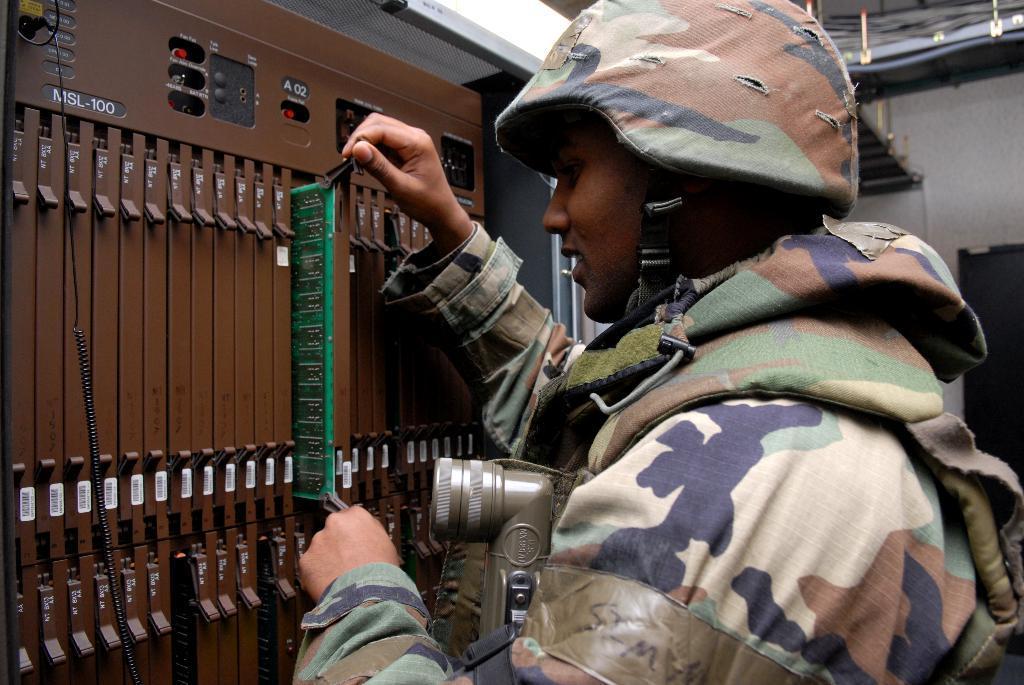Describe this image in one or two sentences. In this image we can see an electrical machine and a person, the person is holding an object and carrying some other object, in the background we can see a wall and other objects. 